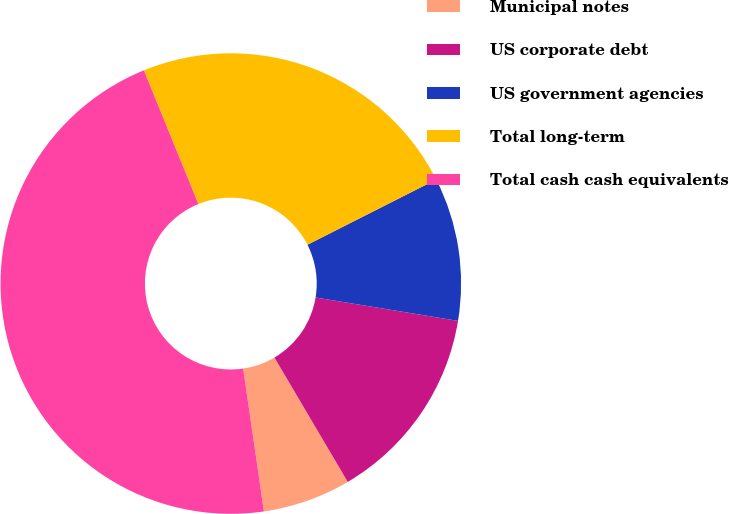Convert chart. <chart><loc_0><loc_0><loc_500><loc_500><pie_chart><fcel>Municipal notes<fcel>US corporate debt<fcel>US government agencies<fcel>Total long-term<fcel>Total cash cash equivalents<nl><fcel>6.18%<fcel>13.93%<fcel>10.05%<fcel>23.7%<fcel>46.13%<nl></chart> 